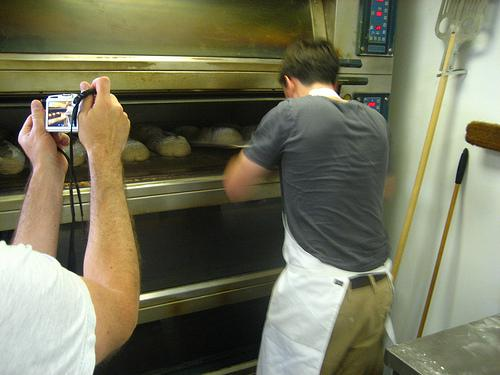Question: what are the men standing in front of?
Choices:
A. A building.
B. An Audience.
C. An oven.
D. A Mirror.
Answer with the letter. Answer: C Question: where is the bread?
Choices:
A. On the table.
B. In the bread box.
C. In the refrigerator.
D. In the oven.
Answer with the letter. Answer: D Question: how is one man holding his camera?
Choices:
A. Around his neck.
B. In his lap.
C. With one hand.
D. With two hands.
Answer with the letter. Answer: D Question: what color is the man's hair?
Choices:
A. Blonde.
B. Grey.
C. Dark brown.
D. Red.
Answer with the letter. Answer: C Question: what color is the shirt worn by the man with the camera?
Choices:
A. Blue.
B. Yellow.
C. Red.
D. Light grey.
Answer with the letter. Answer: D 